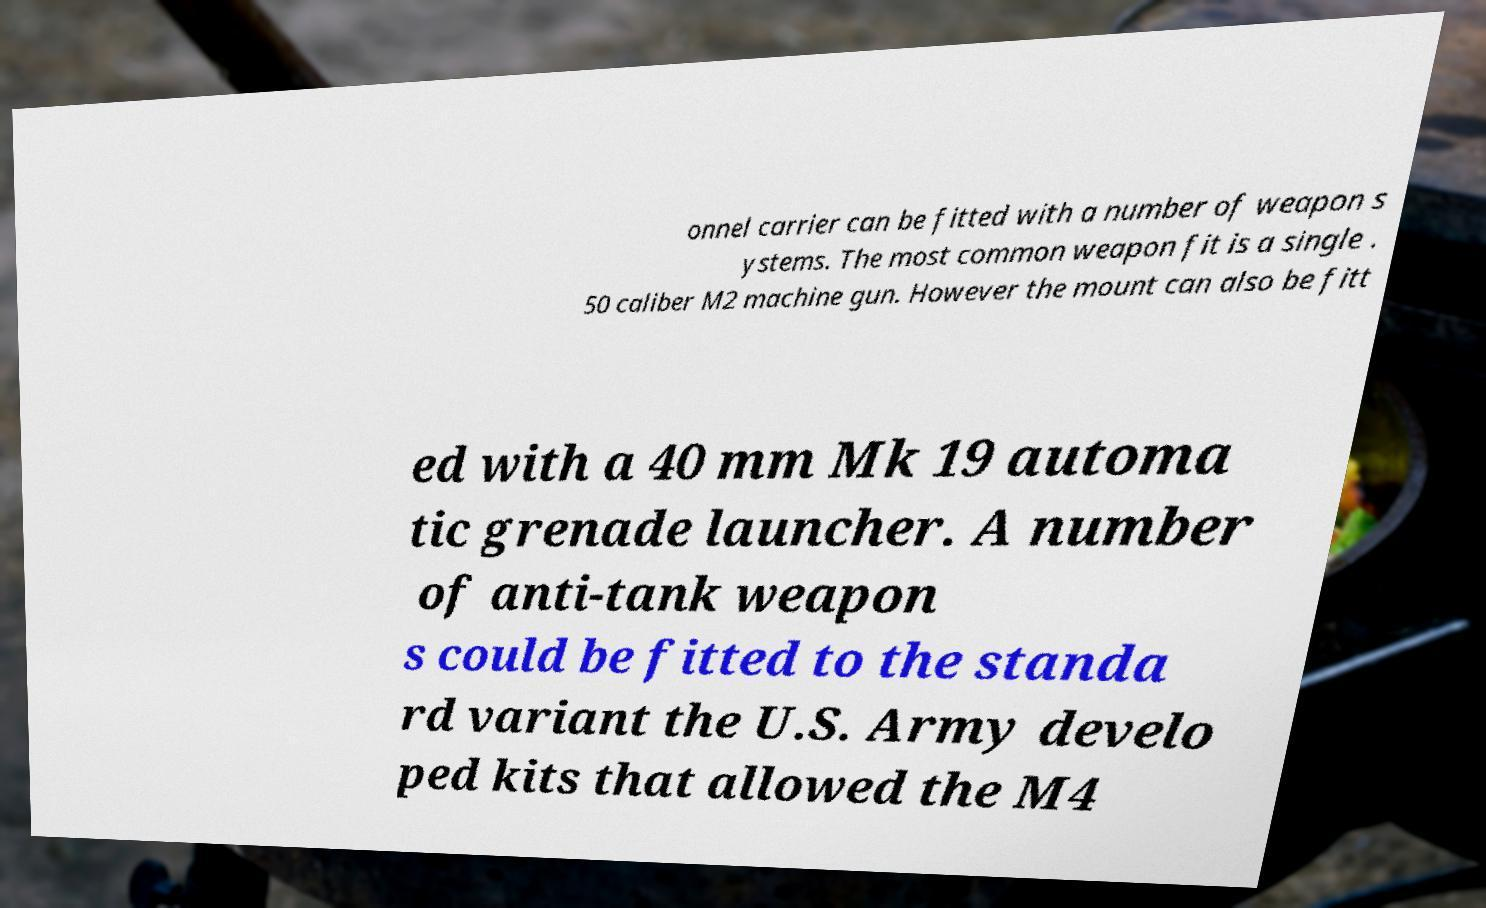Please identify and transcribe the text found in this image. onnel carrier can be fitted with a number of weapon s ystems. The most common weapon fit is a single . 50 caliber M2 machine gun. However the mount can also be fitt ed with a 40 mm Mk 19 automa tic grenade launcher. A number of anti-tank weapon s could be fitted to the standa rd variant the U.S. Army develo ped kits that allowed the M4 